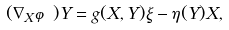Convert formula to latex. <formula><loc_0><loc_0><loc_500><loc_500>( \nabla _ { X } \varphi ) Y = g ( X , Y ) \xi - \eta ( Y ) X ,</formula> 